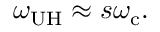Convert formula to latex. <formula><loc_0><loc_0><loc_500><loc_500>\omega _ { U H } \approx s \omega _ { c } .</formula> 